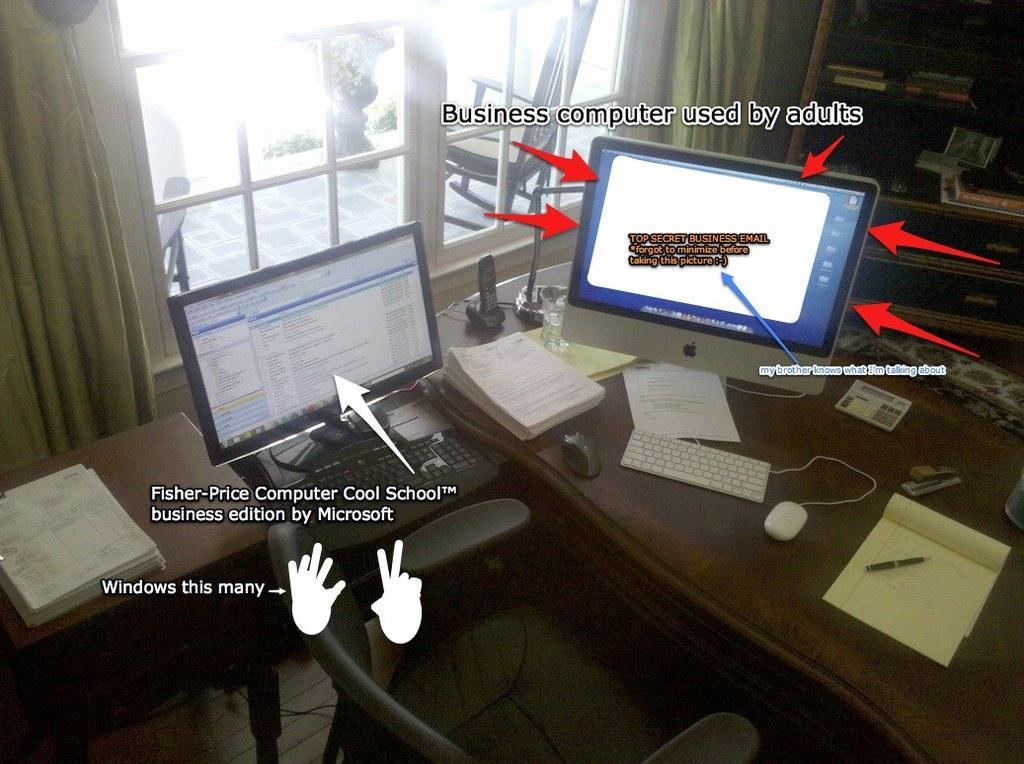Describe this image in one or two sentences. In the foreground of the image we can see a chair placed on the ground. To the left side of the image we can see some papers on the table. In the center of the image we can see screens, keyboard, mouse, telephone, glass, pen and book placed on the table. In the background, we can see books in racks, window, chair, plant and curtains. 